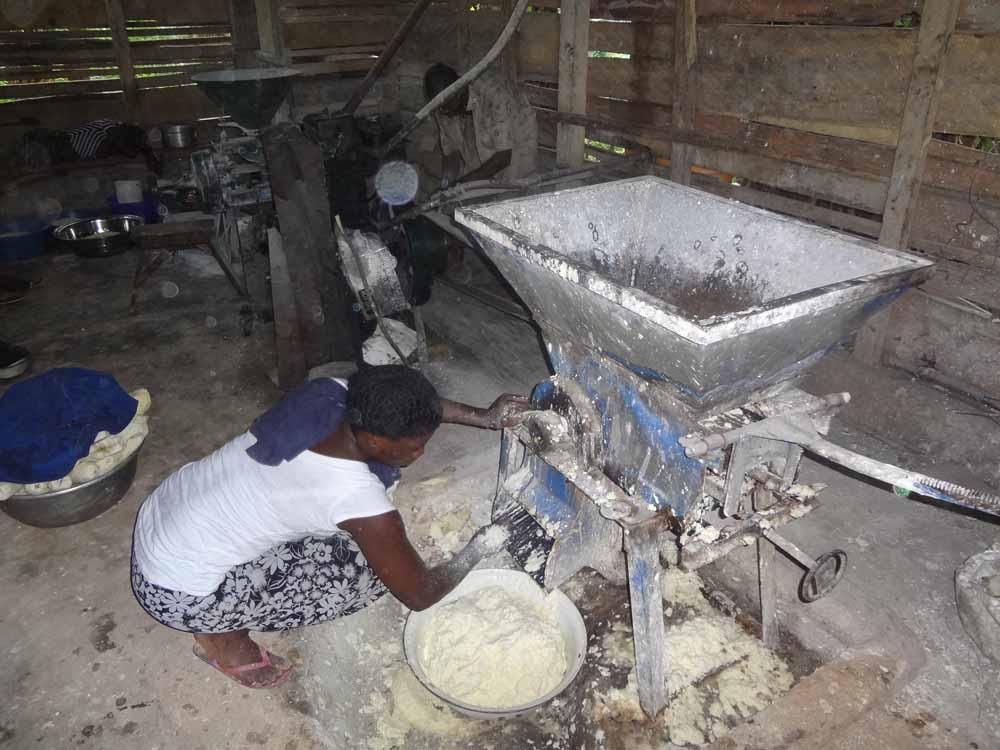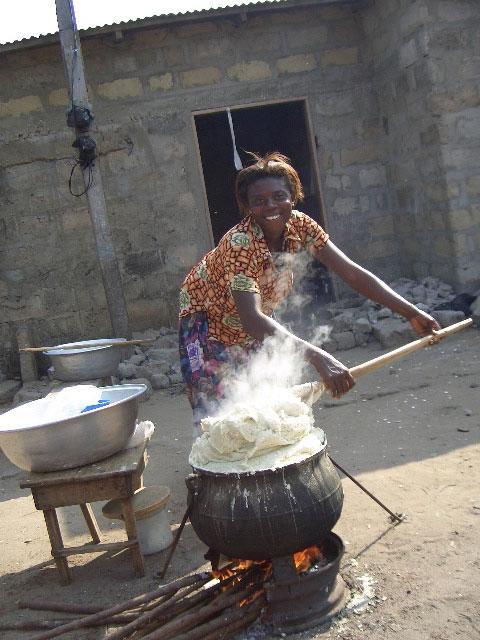The first image is the image on the left, the second image is the image on the right. Analyze the images presented: Is the assertion "One image features one rounded raw dough ball sitting on a flat surface but not in a container." valid? Answer yes or no. No. 